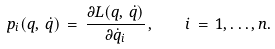Convert formula to latex. <formula><loc_0><loc_0><loc_500><loc_500>p _ { i } ( q , \, \dot { q } ) \, = \, \frac { \partial L ( q , \, \dot { q } ) } { \partial \dot { q } _ { i } } \, { , } \quad i \, = \, 1 , \dots , n .</formula> 